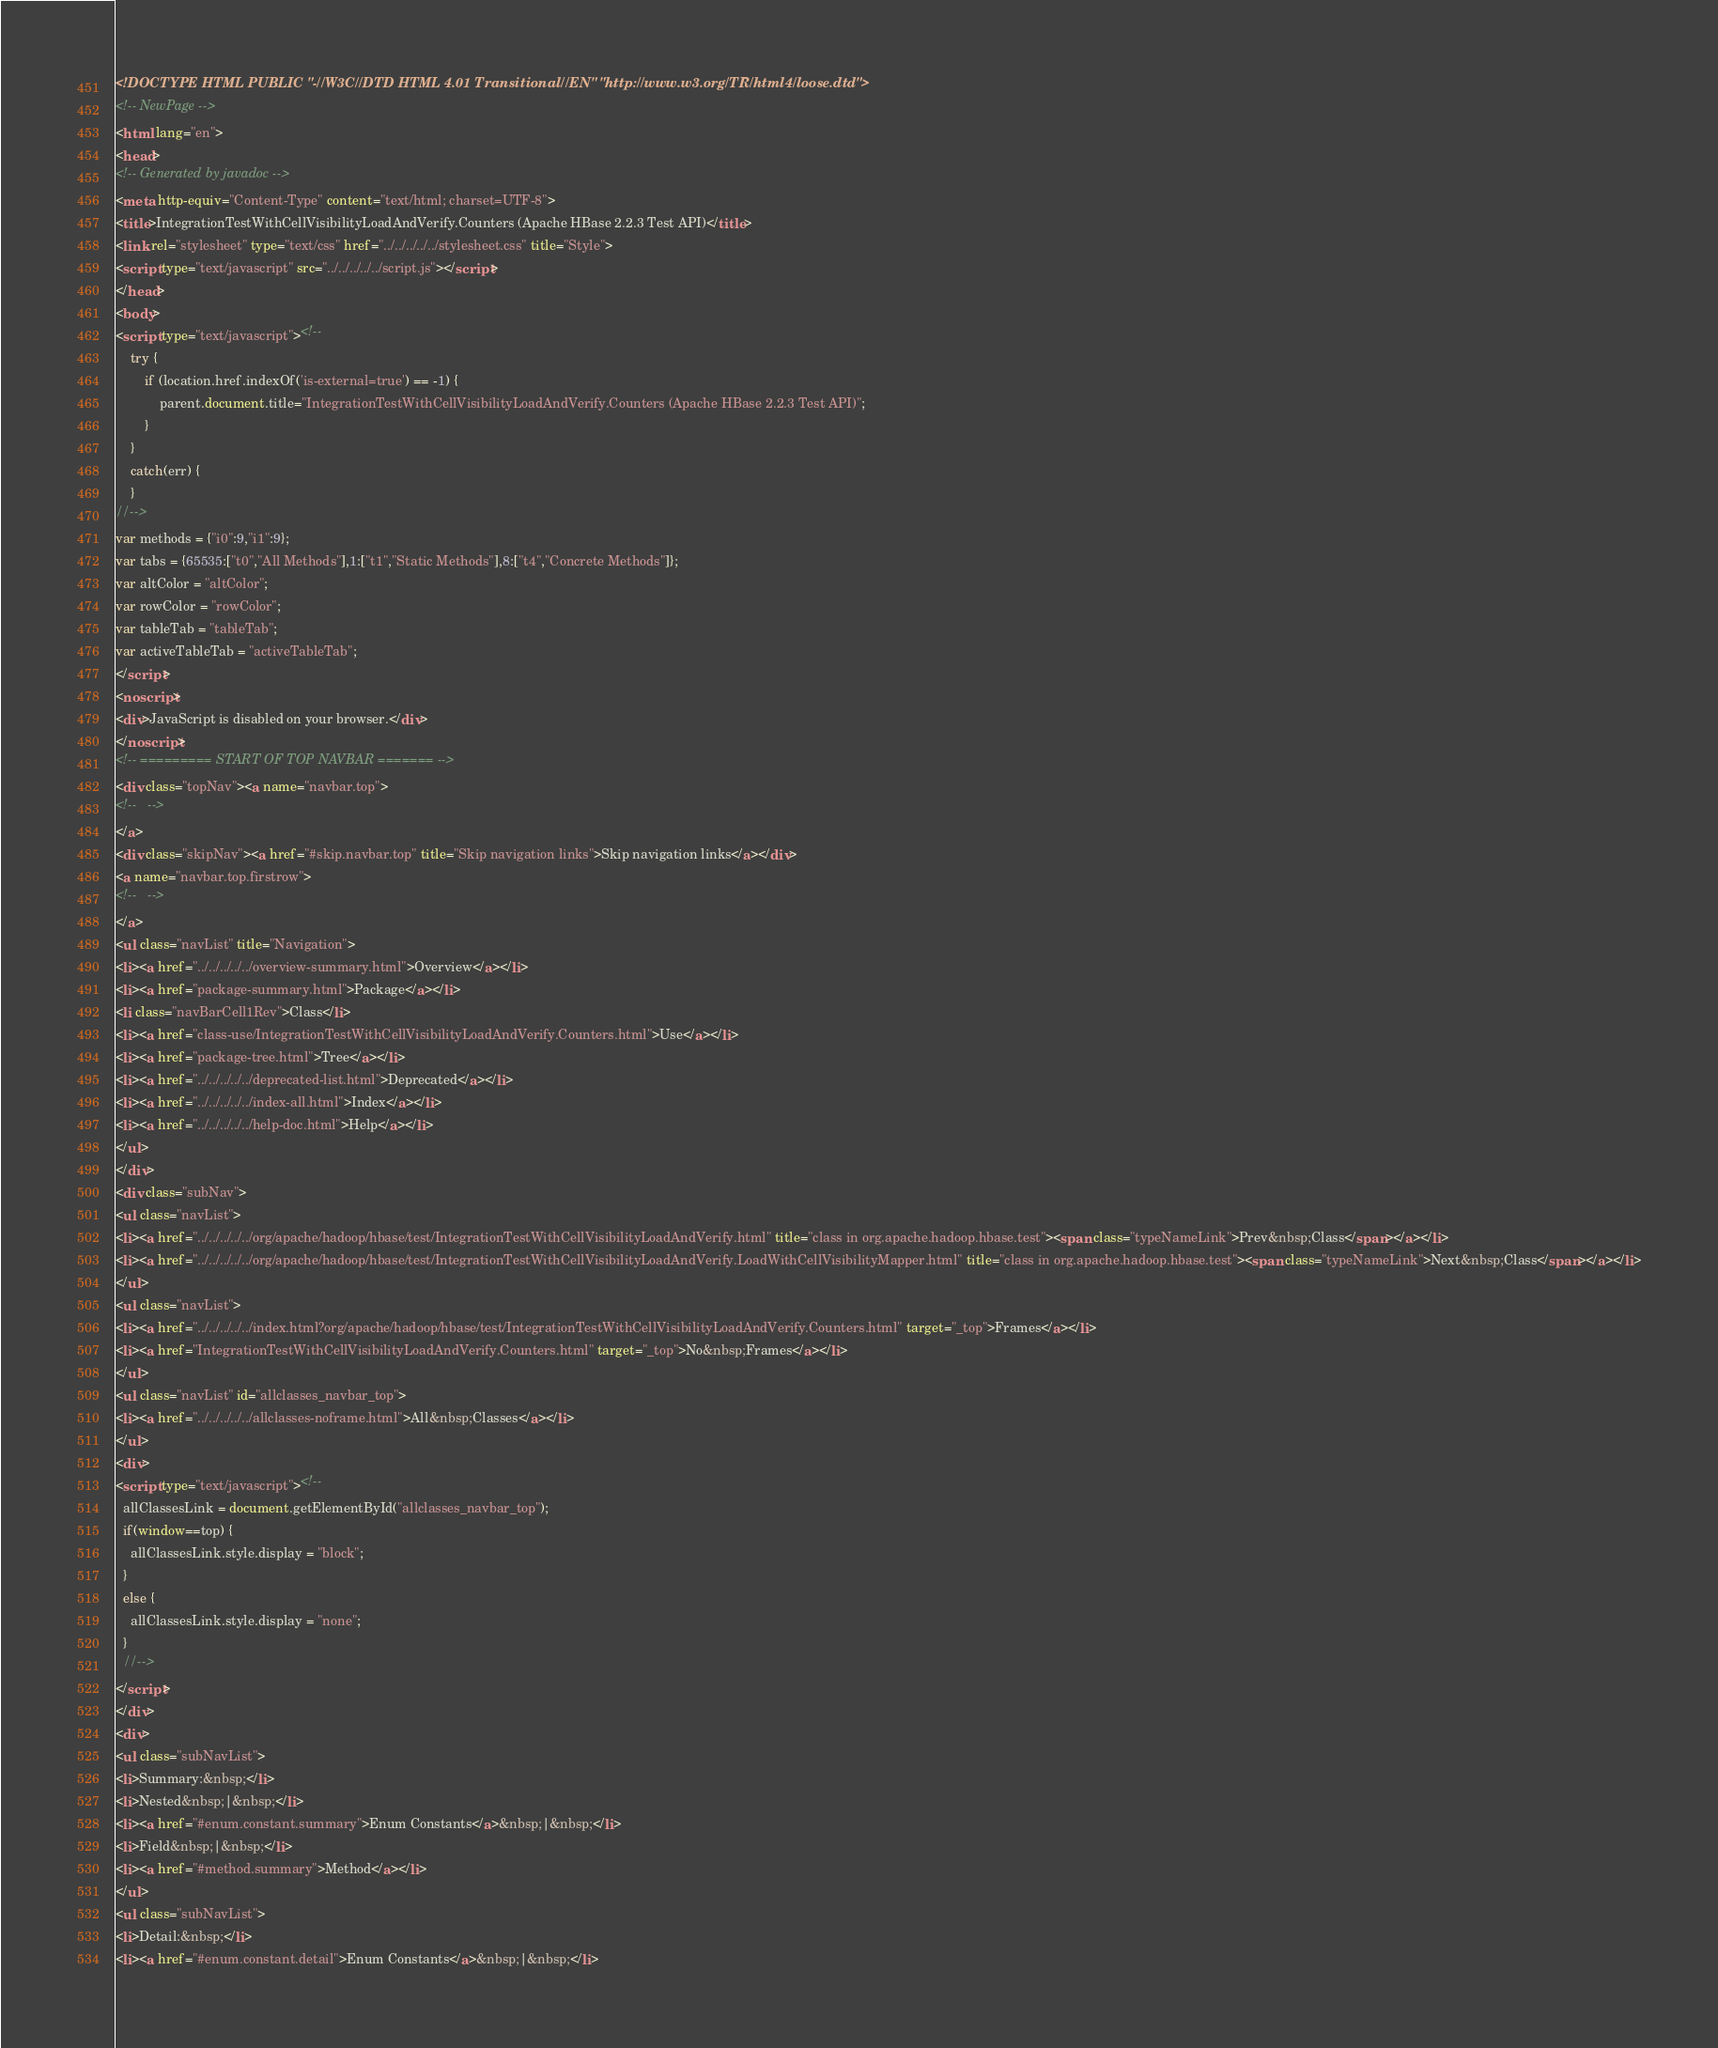<code> <loc_0><loc_0><loc_500><loc_500><_HTML_><!DOCTYPE HTML PUBLIC "-//W3C//DTD HTML 4.01 Transitional//EN" "http://www.w3.org/TR/html4/loose.dtd">
<!-- NewPage -->
<html lang="en">
<head>
<!-- Generated by javadoc -->
<meta http-equiv="Content-Type" content="text/html; charset=UTF-8">
<title>IntegrationTestWithCellVisibilityLoadAndVerify.Counters (Apache HBase 2.2.3 Test API)</title>
<link rel="stylesheet" type="text/css" href="../../../../../stylesheet.css" title="Style">
<script type="text/javascript" src="../../../../../script.js"></script>
</head>
<body>
<script type="text/javascript"><!--
    try {
        if (location.href.indexOf('is-external=true') == -1) {
            parent.document.title="IntegrationTestWithCellVisibilityLoadAndVerify.Counters (Apache HBase 2.2.3 Test API)";
        }
    }
    catch(err) {
    }
//-->
var methods = {"i0":9,"i1":9};
var tabs = {65535:["t0","All Methods"],1:["t1","Static Methods"],8:["t4","Concrete Methods"]};
var altColor = "altColor";
var rowColor = "rowColor";
var tableTab = "tableTab";
var activeTableTab = "activeTableTab";
</script>
<noscript>
<div>JavaScript is disabled on your browser.</div>
</noscript>
<!-- ========= START OF TOP NAVBAR ======= -->
<div class="topNav"><a name="navbar.top">
<!--   -->
</a>
<div class="skipNav"><a href="#skip.navbar.top" title="Skip navigation links">Skip navigation links</a></div>
<a name="navbar.top.firstrow">
<!--   -->
</a>
<ul class="navList" title="Navigation">
<li><a href="../../../../../overview-summary.html">Overview</a></li>
<li><a href="package-summary.html">Package</a></li>
<li class="navBarCell1Rev">Class</li>
<li><a href="class-use/IntegrationTestWithCellVisibilityLoadAndVerify.Counters.html">Use</a></li>
<li><a href="package-tree.html">Tree</a></li>
<li><a href="../../../../../deprecated-list.html">Deprecated</a></li>
<li><a href="../../../../../index-all.html">Index</a></li>
<li><a href="../../../../../help-doc.html">Help</a></li>
</ul>
</div>
<div class="subNav">
<ul class="navList">
<li><a href="../../../../../org/apache/hadoop/hbase/test/IntegrationTestWithCellVisibilityLoadAndVerify.html" title="class in org.apache.hadoop.hbase.test"><span class="typeNameLink">Prev&nbsp;Class</span></a></li>
<li><a href="../../../../../org/apache/hadoop/hbase/test/IntegrationTestWithCellVisibilityLoadAndVerify.LoadWithCellVisibilityMapper.html" title="class in org.apache.hadoop.hbase.test"><span class="typeNameLink">Next&nbsp;Class</span></a></li>
</ul>
<ul class="navList">
<li><a href="../../../../../index.html?org/apache/hadoop/hbase/test/IntegrationTestWithCellVisibilityLoadAndVerify.Counters.html" target="_top">Frames</a></li>
<li><a href="IntegrationTestWithCellVisibilityLoadAndVerify.Counters.html" target="_top">No&nbsp;Frames</a></li>
</ul>
<ul class="navList" id="allclasses_navbar_top">
<li><a href="../../../../../allclasses-noframe.html">All&nbsp;Classes</a></li>
</ul>
<div>
<script type="text/javascript"><!--
  allClassesLink = document.getElementById("allclasses_navbar_top");
  if(window==top) {
    allClassesLink.style.display = "block";
  }
  else {
    allClassesLink.style.display = "none";
  }
  //-->
</script>
</div>
<div>
<ul class="subNavList">
<li>Summary:&nbsp;</li>
<li>Nested&nbsp;|&nbsp;</li>
<li><a href="#enum.constant.summary">Enum Constants</a>&nbsp;|&nbsp;</li>
<li>Field&nbsp;|&nbsp;</li>
<li><a href="#method.summary">Method</a></li>
</ul>
<ul class="subNavList">
<li>Detail:&nbsp;</li>
<li><a href="#enum.constant.detail">Enum Constants</a>&nbsp;|&nbsp;</li></code> 